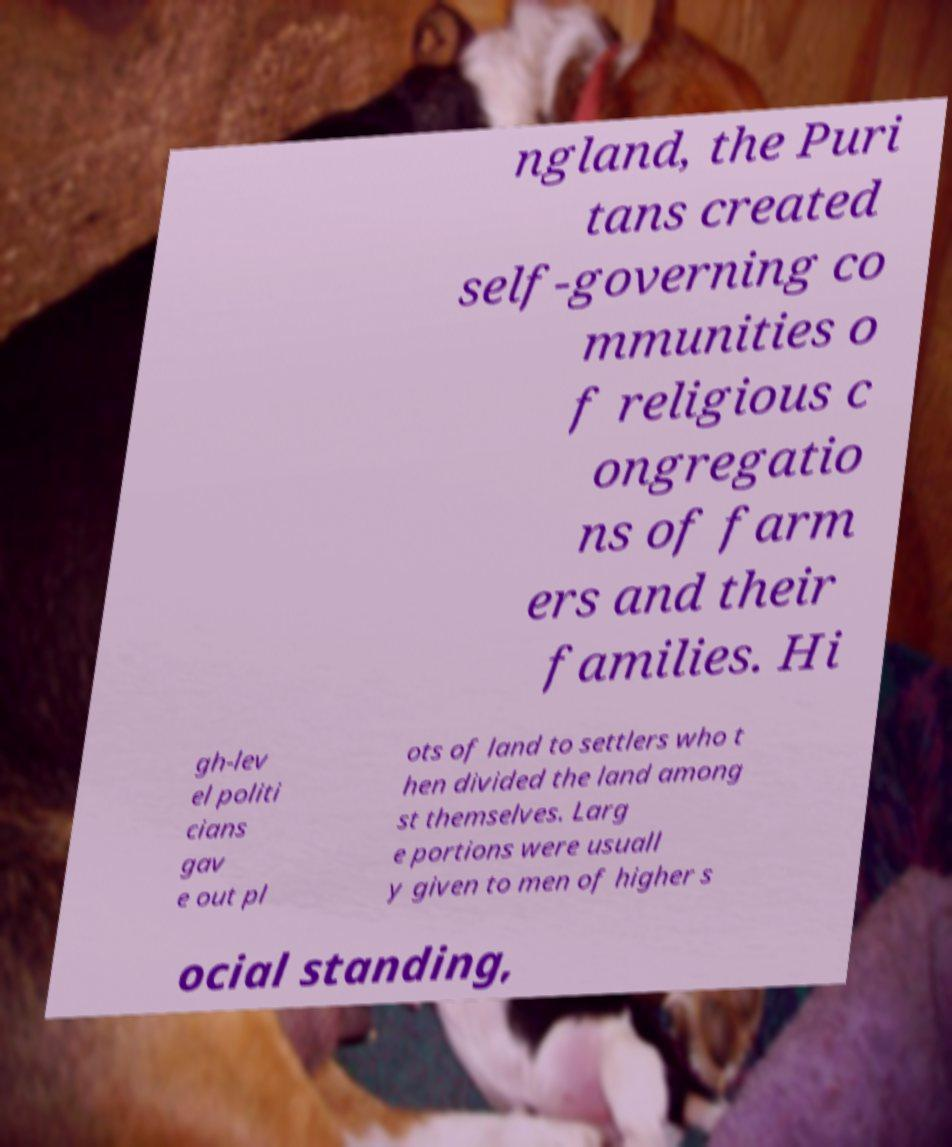Please read and relay the text visible in this image. What does it say? ngland, the Puri tans created self-governing co mmunities o f religious c ongregatio ns of farm ers and their families. Hi gh-lev el politi cians gav e out pl ots of land to settlers who t hen divided the land among st themselves. Larg e portions were usuall y given to men of higher s ocial standing, 